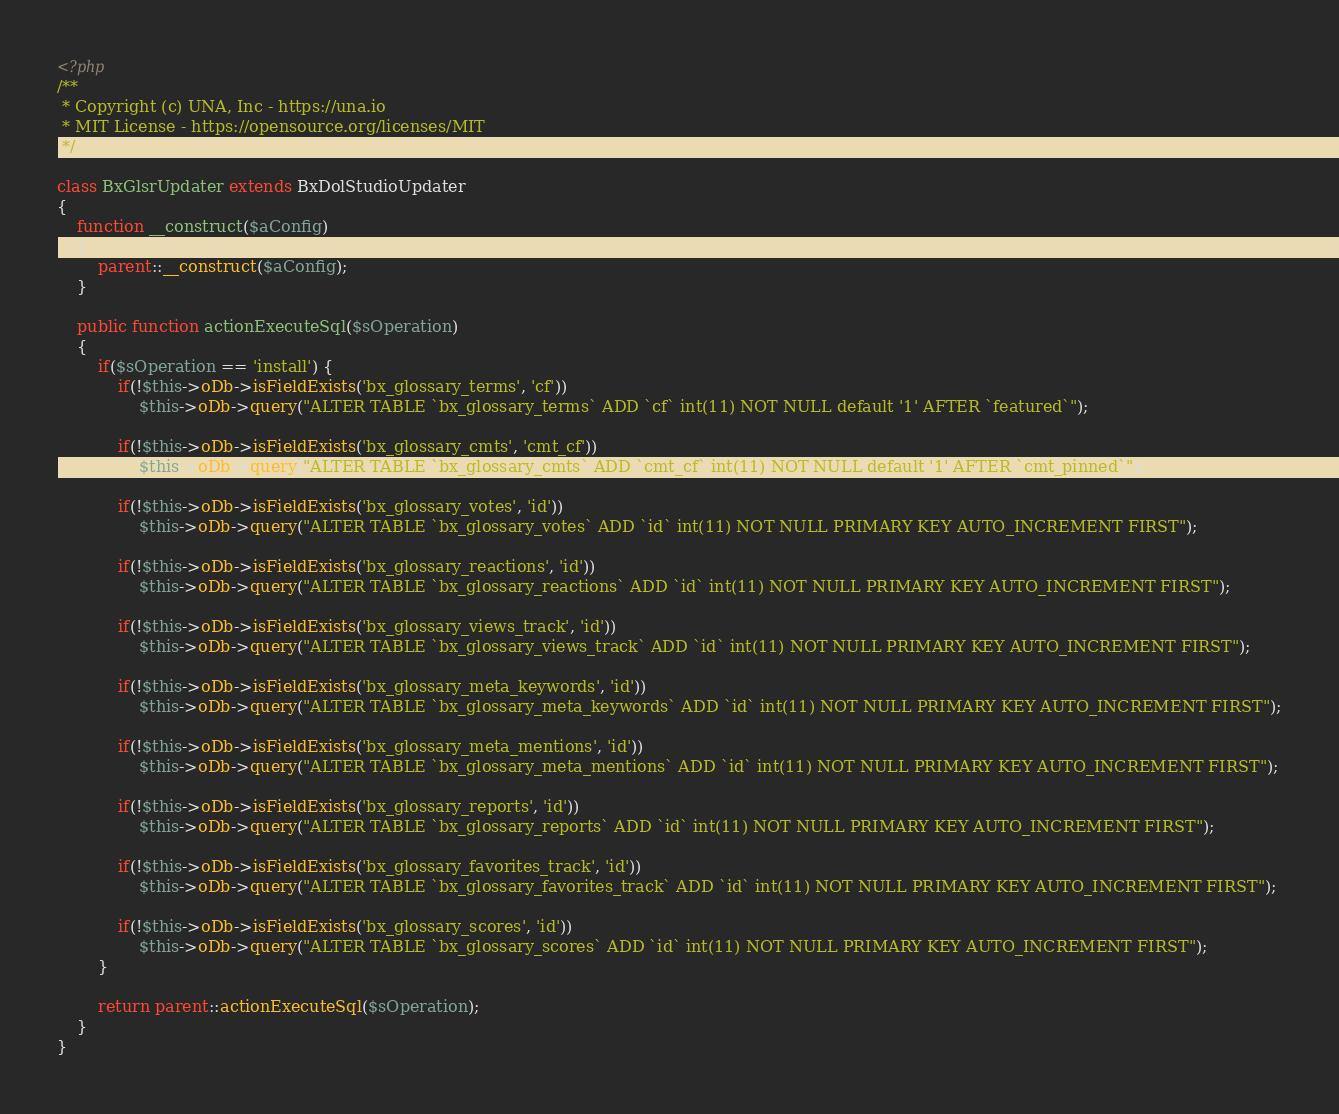Convert code to text. <code><loc_0><loc_0><loc_500><loc_500><_PHP_><?php
/**
 * Copyright (c) UNA, Inc - https://una.io
 * MIT License - https://opensource.org/licenses/MIT
 */

class BxGlsrUpdater extends BxDolStudioUpdater
{
    function __construct($aConfig)
    {
        parent::__construct($aConfig);
    }

    public function actionExecuteSql($sOperation)
    {
        if($sOperation == 'install') {
            if(!$this->oDb->isFieldExists('bx_glossary_terms', 'cf'))
                $this->oDb->query("ALTER TABLE `bx_glossary_terms` ADD `cf` int(11) NOT NULL default '1' AFTER `featured`");

            if(!$this->oDb->isFieldExists('bx_glossary_cmts', 'cmt_cf'))
                $this->oDb->query("ALTER TABLE `bx_glossary_cmts` ADD `cmt_cf` int(11) NOT NULL default '1' AFTER `cmt_pinned`");

            if(!$this->oDb->isFieldExists('bx_glossary_votes', 'id'))
                $this->oDb->query("ALTER TABLE `bx_glossary_votes` ADD `id` int(11) NOT NULL PRIMARY KEY AUTO_INCREMENT FIRST");

            if(!$this->oDb->isFieldExists('bx_glossary_reactions', 'id'))
                $this->oDb->query("ALTER TABLE `bx_glossary_reactions` ADD `id` int(11) NOT NULL PRIMARY KEY AUTO_INCREMENT FIRST");

            if(!$this->oDb->isFieldExists('bx_glossary_views_track', 'id'))
                $this->oDb->query("ALTER TABLE `bx_glossary_views_track` ADD `id` int(11) NOT NULL PRIMARY KEY AUTO_INCREMENT FIRST");

            if(!$this->oDb->isFieldExists('bx_glossary_meta_keywords', 'id'))
                $this->oDb->query("ALTER TABLE `bx_glossary_meta_keywords` ADD `id` int(11) NOT NULL PRIMARY KEY AUTO_INCREMENT FIRST");

            if(!$this->oDb->isFieldExists('bx_glossary_meta_mentions', 'id'))
                $this->oDb->query("ALTER TABLE `bx_glossary_meta_mentions` ADD `id` int(11) NOT NULL PRIMARY KEY AUTO_INCREMENT FIRST");

            if(!$this->oDb->isFieldExists('bx_glossary_reports', 'id'))
                $this->oDb->query("ALTER TABLE `bx_glossary_reports` ADD `id` int(11) NOT NULL PRIMARY KEY AUTO_INCREMENT FIRST");

            if(!$this->oDb->isFieldExists('bx_glossary_favorites_track', 'id'))
                $this->oDb->query("ALTER TABLE `bx_glossary_favorites_track` ADD `id` int(11) NOT NULL PRIMARY KEY AUTO_INCREMENT FIRST");

            if(!$this->oDb->isFieldExists('bx_glossary_scores', 'id'))
                $this->oDb->query("ALTER TABLE `bx_glossary_scores` ADD `id` int(11) NOT NULL PRIMARY KEY AUTO_INCREMENT FIRST");
        }

        return parent::actionExecuteSql($sOperation);
    }
}
</code> 